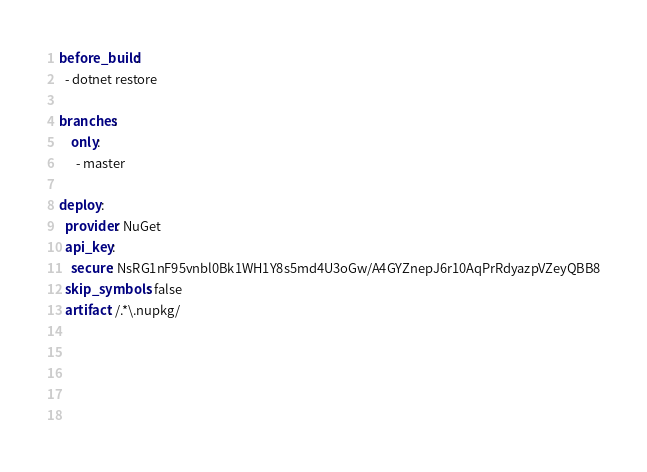<code> <loc_0><loc_0><loc_500><loc_500><_YAML_>before_build:
  - dotnet restore
  
branches:
    only:
      - master

deploy:
  provider: NuGet
  api_key:
    secure: NsRG1nF95vnbl0Bk1WH1Y8s5md4U3oGw/A4GYZnepJ6r10AqPrRdyazpVZeyQBB8
  skip_symbols: false
  artifact: /.*\.nupkg/
  
    

  
  


</code> 